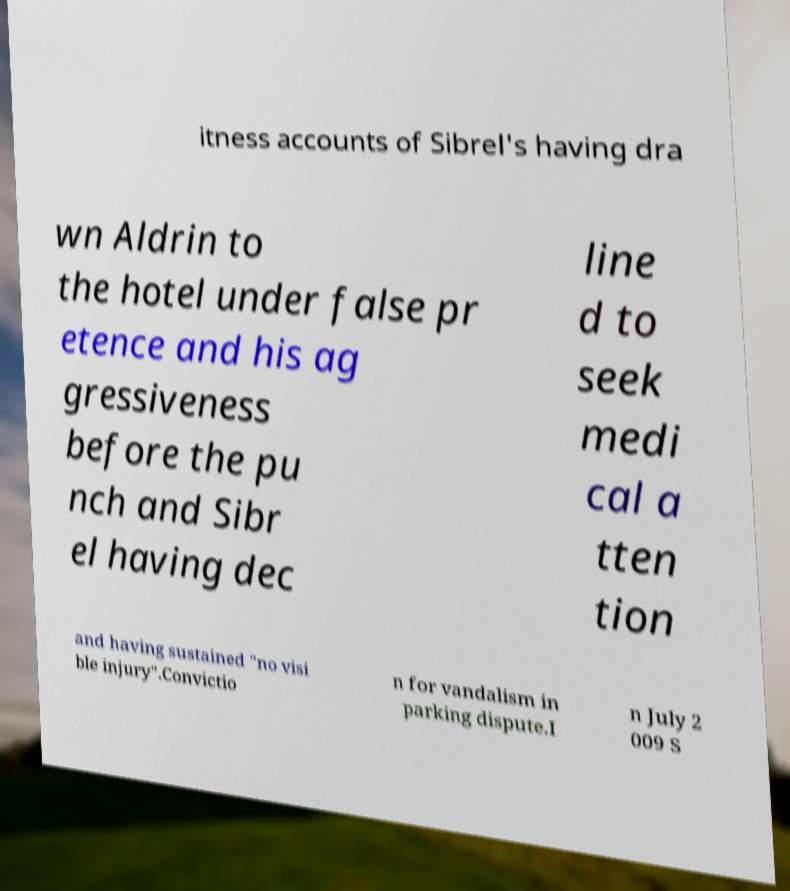For documentation purposes, I need the text within this image transcribed. Could you provide that? itness accounts of Sibrel's having dra wn Aldrin to the hotel under false pr etence and his ag gressiveness before the pu nch and Sibr el having dec line d to seek medi cal a tten tion and having sustained "no visi ble injury".Convictio n for vandalism in parking dispute.I n July 2 009 S 